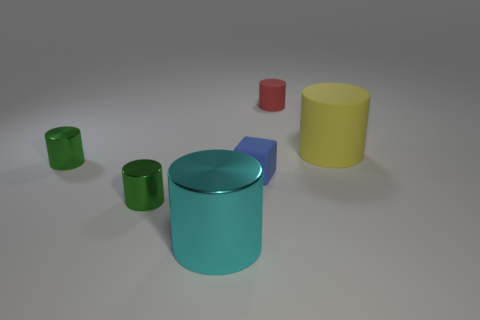Subtract all red cylinders. How many cylinders are left? 4 Subtract all cyan cylinders. How many cylinders are left? 4 Subtract all brown cylinders. Subtract all gray cubes. How many cylinders are left? 5 Add 3 yellow shiny blocks. How many objects exist? 9 Subtract all blocks. How many objects are left? 5 Add 1 big cyan metal things. How many big cyan metal things exist? 2 Subtract 0 brown cylinders. How many objects are left? 6 Subtract all red rubber balls. Subtract all big rubber cylinders. How many objects are left? 5 Add 6 tiny metal objects. How many tiny metal objects are left? 8 